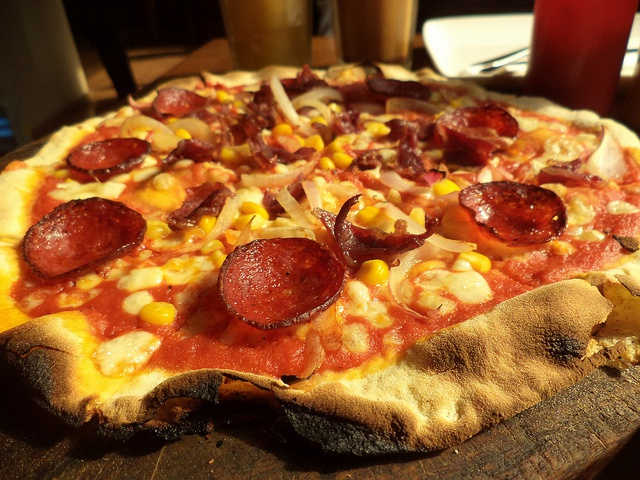Describe the objects in this image and their specific colors. I can see pizza in black, maroon, brown, orange, and red tones, cup in black and maroon tones, cup in black, maroon, and olive tones, and cup in black, maroon, and olive tones in this image. 